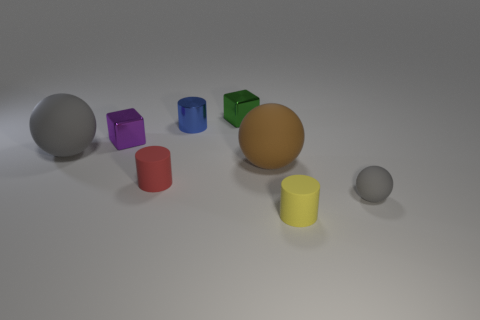There is a big sphere that is on the right side of the rubber cylinder that is behind the matte ball that is on the right side of the tiny yellow rubber cylinder; what color is it?
Keep it short and to the point. Brown. Does the small metal thing that is to the left of the small red cylinder have the same color as the rubber sphere that is to the left of the brown matte sphere?
Give a very brief answer. No. What is the shape of the gray thing to the right of the green metal cube left of the big brown rubber sphere?
Provide a short and direct response. Sphere. Are there any brown metal cylinders that have the same size as the brown matte ball?
Offer a very short reply. No. How many red things have the same shape as the tiny yellow rubber object?
Keep it short and to the point. 1. Is the number of brown matte objects to the right of the yellow rubber cylinder the same as the number of big brown spheres behind the tiny blue cylinder?
Ensure brevity in your answer.  Yes. Is there a rubber cylinder?
Offer a very short reply. Yes. What size is the gray matte sphere that is behind the small sphere in front of the large rubber sphere that is to the left of the blue cylinder?
Give a very brief answer. Large. The green shiny thing that is the same size as the yellow object is what shape?
Your answer should be compact. Cube. How many objects are either cubes in front of the blue metal thing or cylinders?
Keep it short and to the point. 4. 